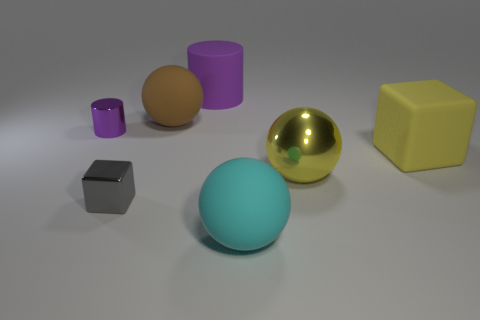Subtract all yellow metallic spheres. How many spheres are left? 2 Add 2 cyan objects. How many objects exist? 9 Subtract all yellow balls. How many balls are left? 2 Subtract 1 yellow blocks. How many objects are left? 6 Subtract all cylinders. How many objects are left? 5 Subtract all cyan blocks. Subtract all cyan cylinders. How many blocks are left? 2 Subtract all big purple cylinders. Subtract all small gray shiny things. How many objects are left? 5 Add 6 big cyan balls. How many big cyan balls are left? 7 Add 7 yellow rubber cubes. How many yellow rubber cubes exist? 8 